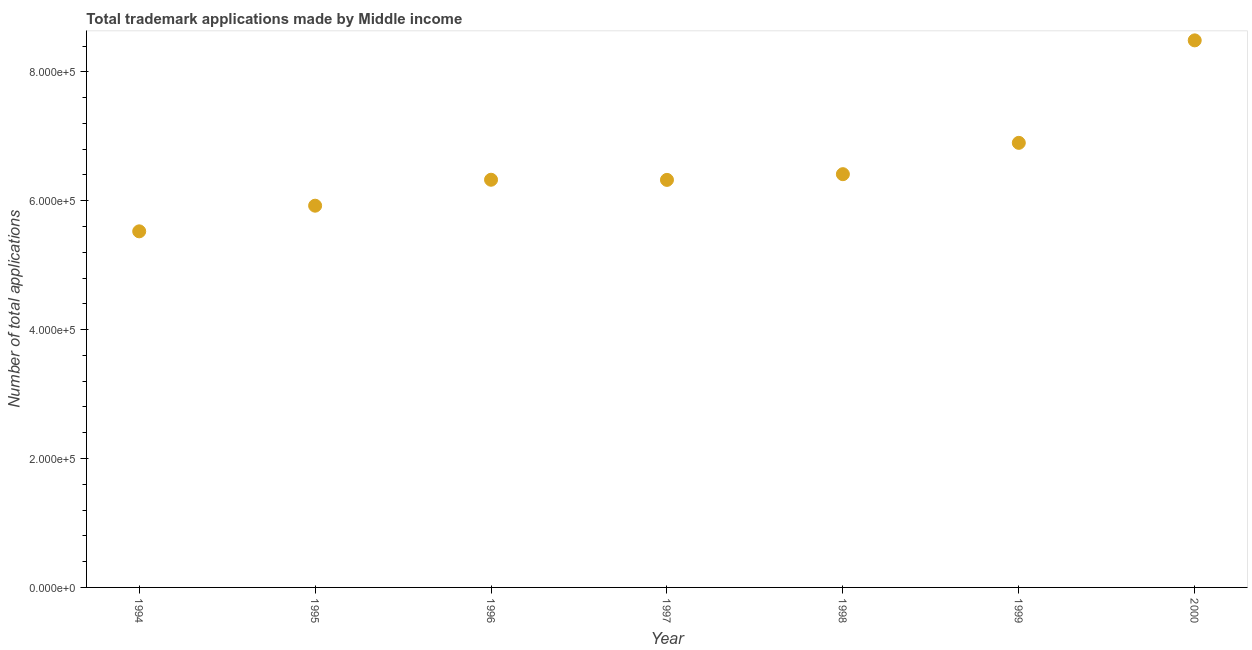What is the number of trademark applications in 1999?
Keep it short and to the point. 6.90e+05. Across all years, what is the maximum number of trademark applications?
Your answer should be compact. 8.49e+05. Across all years, what is the minimum number of trademark applications?
Keep it short and to the point. 5.52e+05. In which year was the number of trademark applications minimum?
Provide a short and direct response. 1994. What is the sum of the number of trademark applications?
Provide a succinct answer. 4.59e+06. What is the difference between the number of trademark applications in 1994 and 1996?
Ensure brevity in your answer.  -8.01e+04. What is the average number of trademark applications per year?
Keep it short and to the point. 6.56e+05. What is the median number of trademark applications?
Your response must be concise. 6.33e+05. What is the ratio of the number of trademark applications in 1996 to that in 1998?
Provide a succinct answer. 0.99. What is the difference between the highest and the second highest number of trademark applications?
Provide a succinct answer. 1.59e+05. What is the difference between the highest and the lowest number of trademark applications?
Your answer should be very brief. 2.96e+05. In how many years, is the number of trademark applications greater than the average number of trademark applications taken over all years?
Offer a terse response. 2. What is the difference between two consecutive major ticks on the Y-axis?
Ensure brevity in your answer.  2.00e+05. Does the graph contain any zero values?
Keep it short and to the point. No. Does the graph contain grids?
Your response must be concise. No. What is the title of the graph?
Make the answer very short. Total trademark applications made by Middle income. What is the label or title of the Y-axis?
Your answer should be very brief. Number of total applications. What is the Number of total applications in 1994?
Your answer should be very brief. 5.52e+05. What is the Number of total applications in 1995?
Ensure brevity in your answer.  5.92e+05. What is the Number of total applications in 1996?
Your answer should be very brief. 6.33e+05. What is the Number of total applications in 1997?
Your answer should be very brief. 6.32e+05. What is the Number of total applications in 1998?
Provide a short and direct response. 6.41e+05. What is the Number of total applications in 1999?
Make the answer very short. 6.90e+05. What is the Number of total applications in 2000?
Make the answer very short. 8.49e+05. What is the difference between the Number of total applications in 1994 and 1995?
Provide a short and direct response. -3.98e+04. What is the difference between the Number of total applications in 1994 and 1996?
Offer a very short reply. -8.01e+04. What is the difference between the Number of total applications in 1994 and 1997?
Your answer should be compact. -7.98e+04. What is the difference between the Number of total applications in 1994 and 1998?
Provide a short and direct response. -8.87e+04. What is the difference between the Number of total applications in 1994 and 1999?
Keep it short and to the point. -1.37e+05. What is the difference between the Number of total applications in 1994 and 2000?
Your answer should be very brief. -2.96e+05. What is the difference between the Number of total applications in 1995 and 1996?
Provide a succinct answer. -4.03e+04. What is the difference between the Number of total applications in 1995 and 1997?
Give a very brief answer. -4.00e+04. What is the difference between the Number of total applications in 1995 and 1998?
Offer a terse response. -4.89e+04. What is the difference between the Number of total applications in 1995 and 1999?
Keep it short and to the point. -9.75e+04. What is the difference between the Number of total applications in 1995 and 2000?
Give a very brief answer. -2.57e+05. What is the difference between the Number of total applications in 1996 and 1997?
Give a very brief answer. 223. What is the difference between the Number of total applications in 1996 and 1998?
Keep it short and to the point. -8640. What is the difference between the Number of total applications in 1996 and 1999?
Make the answer very short. -5.72e+04. What is the difference between the Number of total applications in 1996 and 2000?
Offer a terse response. -2.16e+05. What is the difference between the Number of total applications in 1997 and 1998?
Offer a terse response. -8863. What is the difference between the Number of total applications in 1997 and 1999?
Offer a terse response. -5.75e+04. What is the difference between the Number of total applications in 1997 and 2000?
Ensure brevity in your answer.  -2.16e+05. What is the difference between the Number of total applications in 1998 and 1999?
Ensure brevity in your answer.  -4.86e+04. What is the difference between the Number of total applications in 1998 and 2000?
Keep it short and to the point. -2.08e+05. What is the difference between the Number of total applications in 1999 and 2000?
Keep it short and to the point. -1.59e+05. What is the ratio of the Number of total applications in 1994 to that in 1995?
Ensure brevity in your answer.  0.93. What is the ratio of the Number of total applications in 1994 to that in 1996?
Ensure brevity in your answer.  0.87. What is the ratio of the Number of total applications in 1994 to that in 1997?
Your answer should be compact. 0.87. What is the ratio of the Number of total applications in 1994 to that in 1998?
Offer a terse response. 0.86. What is the ratio of the Number of total applications in 1994 to that in 1999?
Offer a terse response. 0.8. What is the ratio of the Number of total applications in 1994 to that in 2000?
Ensure brevity in your answer.  0.65. What is the ratio of the Number of total applications in 1995 to that in 1996?
Your response must be concise. 0.94. What is the ratio of the Number of total applications in 1995 to that in 1997?
Give a very brief answer. 0.94. What is the ratio of the Number of total applications in 1995 to that in 1998?
Provide a short and direct response. 0.92. What is the ratio of the Number of total applications in 1995 to that in 1999?
Ensure brevity in your answer.  0.86. What is the ratio of the Number of total applications in 1995 to that in 2000?
Offer a terse response. 0.7. What is the ratio of the Number of total applications in 1996 to that in 1998?
Your answer should be compact. 0.99. What is the ratio of the Number of total applications in 1996 to that in 1999?
Give a very brief answer. 0.92. What is the ratio of the Number of total applications in 1996 to that in 2000?
Your answer should be very brief. 0.74. What is the ratio of the Number of total applications in 1997 to that in 1998?
Provide a succinct answer. 0.99. What is the ratio of the Number of total applications in 1997 to that in 1999?
Provide a short and direct response. 0.92. What is the ratio of the Number of total applications in 1997 to that in 2000?
Offer a terse response. 0.74. What is the ratio of the Number of total applications in 1998 to that in 2000?
Offer a terse response. 0.76. What is the ratio of the Number of total applications in 1999 to that in 2000?
Make the answer very short. 0.81. 